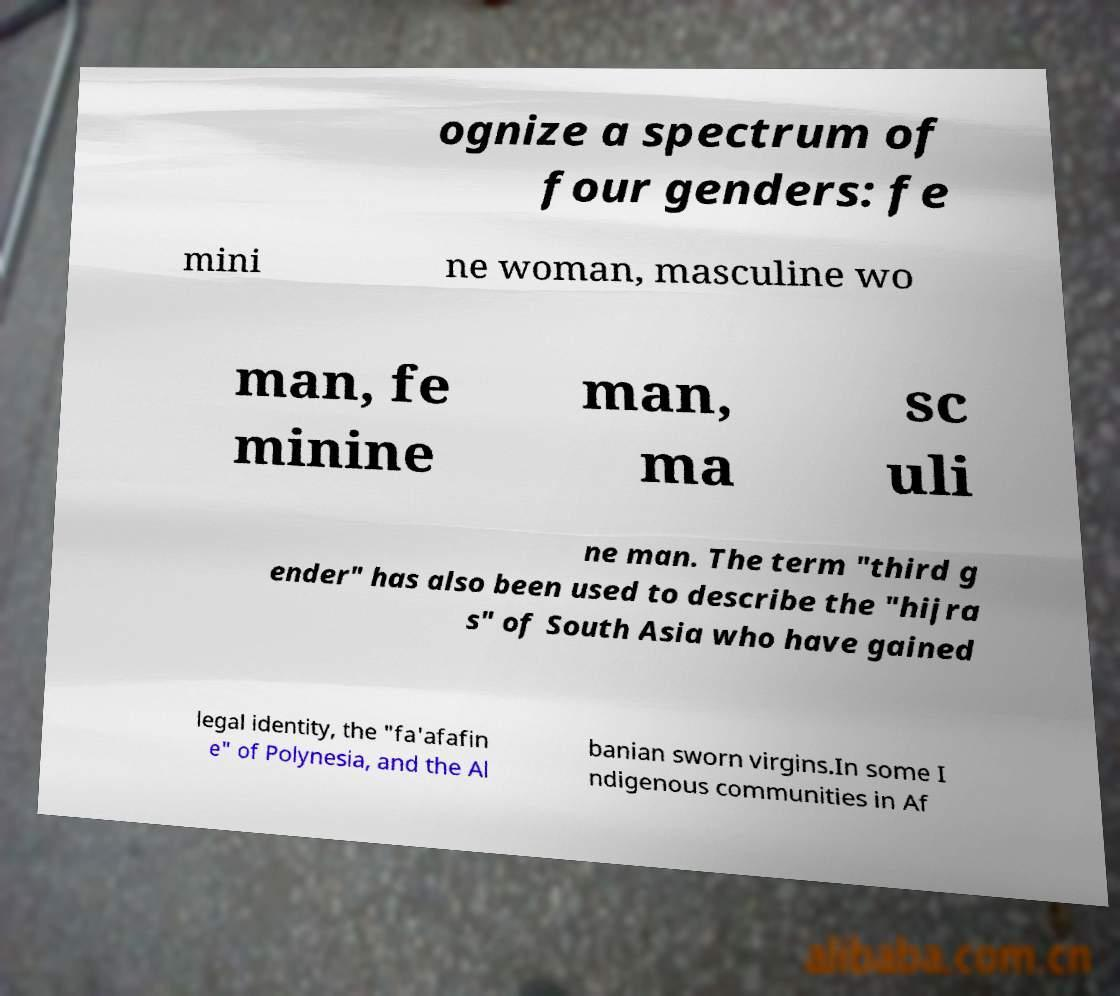What messages or text are displayed in this image? I need them in a readable, typed format. ognize a spectrum of four genders: fe mini ne woman, masculine wo man, fe minine man, ma sc uli ne man. The term "third g ender" has also been used to describe the "hijra s" of South Asia who have gained legal identity, the "fa'afafin e" of Polynesia, and the Al banian sworn virgins.In some I ndigenous communities in Af 